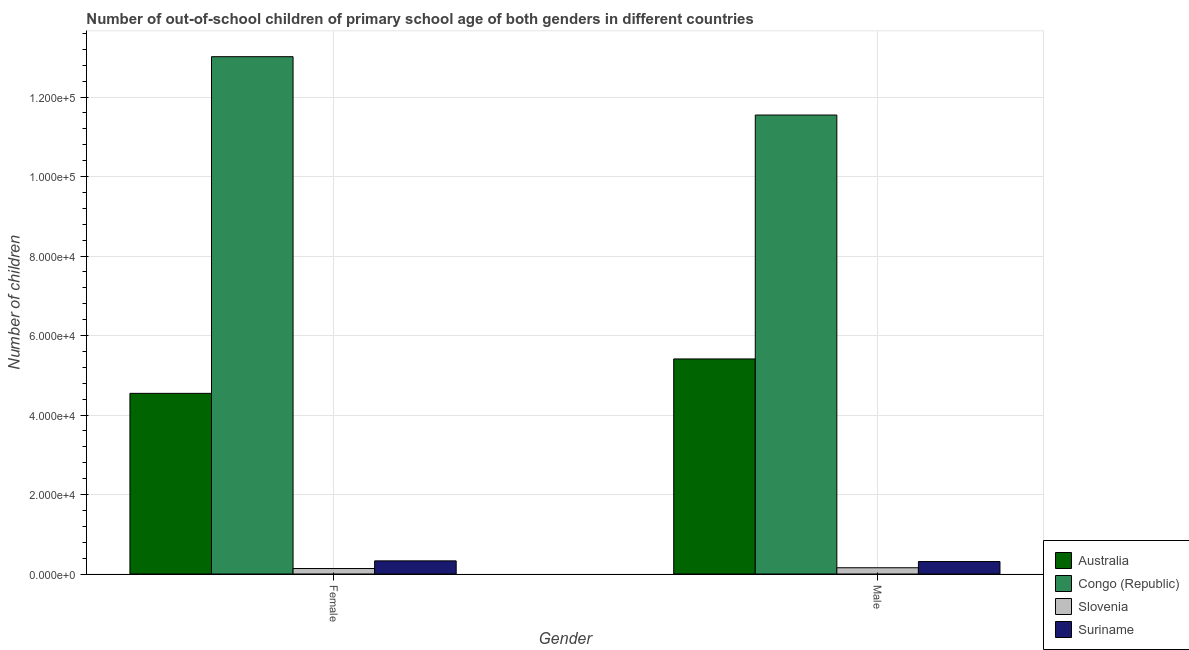Are the number of bars on each tick of the X-axis equal?
Provide a succinct answer. Yes. How many bars are there on the 2nd tick from the right?
Your answer should be very brief. 4. What is the label of the 1st group of bars from the left?
Offer a very short reply. Female. What is the number of male out-of-school students in Australia?
Your response must be concise. 5.41e+04. Across all countries, what is the maximum number of male out-of-school students?
Your answer should be compact. 1.15e+05. Across all countries, what is the minimum number of female out-of-school students?
Give a very brief answer. 1377. In which country was the number of male out-of-school students maximum?
Your answer should be compact. Congo (Republic). In which country was the number of female out-of-school students minimum?
Provide a succinct answer. Slovenia. What is the total number of male out-of-school students in the graph?
Your answer should be compact. 1.74e+05. What is the difference between the number of male out-of-school students in Suriname and that in Australia?
Provide a succinct answer. -5.10e+04. What is the difference between the number of female out-of-school students in Suriname and the number of male out-of-school students in Congo (Republic)?
Your answer should be very brief. -1.12e+05. What is the average number of male out-of-school students per country?
Provide a succinct answer. 4.36e+04. What is the difference between the number of female out-of-school students and number of male out-of-school students in Congo (Republic)?
Provide a succinct answer. 1.47e+04. In how many countries, is the number of female out-of-school students greater than 120000 ?
Your answer should be compact. 1. What is the ratio of the number of female out-of-school students in Slovenia to that in Suriname?
Give a very brief answer. 0.42. In how many countries, is the number of male out-of-school students greater than the average number of male out-of-school students taken over all countries?
Offer a terse response. 2. What does the 4th bar from the right in Female represents?
Offer a very short reply. Australia. How many bars are there?
Your response must be concise. 8. Are all the bars in the graph horizontal?
Your answer should be very brief. No. What is the difference between two consecutive major ticks on the Y-axis?
Your answer should be compact. 2.00e+04. Does the graph contain any zero values?
Provide a succinct answer. No. Does the graph contain grids?
Your response must be concise. Yes. How are the legend labels stacked?
Keep it short and to the point. Vertical. What is the title of the graph?
Provide a succinct answer. Number of out-of-school children of primary school age of both genders in different countries. What is the label or title of the X-axis?
Offer a terse response. Gender. What is the label or title of the Y-axis?
Provide a short and direct response. Number of children. What is the Number of children in Australia in Female?
Your answer should be compact. 4.54e+04. What is the Number of children in Congo (Republic) in Female?
Offer a terse response. 1.30e+05. What is the Number of children in Slovenia in Female?
Provide a short and direct response. 1377. What is the Number of children in Suriname in Female?
Make the answer very short. 3305. What is the Number of children in Australia in Male?
Offer a very short reply. 5.41e+04. What is the Number of children in Congo (Republic) in Male?
Your response must be concise. 1.15e+05. What is the Number of children of Slovenia in Male?
Offer a very short reply. 1572. What is the Number of children of Suriname in Male?
Offer a terse response. 3139. Across all Gender, what is the maximum Number of children of Australia?
Keep it short and to the point. 5.41e+04. Across all Gender, what is the maximum Number of children in Congo (Republic)?
Your answer should be very brief. 1.30e+05. Across all Gender, what is the maximum Number of children of Slovenia?
Give a very brief answer. 1572. Across all Gender, what is the maximum Number of children of Suriname?
Provide a succinct answer. 3305. Across all Gender, what is the minimum Number of children of Australia?
Offer a terse response. 4.54e+04. Across all Gender, what is the minimum Number of children of Congo (Republic)?
Provide a succinct answer. 1.15e+05. Across all Gender, what is the minimum Number of children of Slovenia?
Make the answer very short. 1377. Across all Gender, what is the minimum Number of children in Suriname?
Provide a short and direct response. 3139. What is the total Number of children of Australia in the graph?
Your answer should be compact. 9.96e+04. What is the total Number of children of Congo (Republic) in the graph?
Your response must be concise. 2.46e+05. What is the total Number of children of Slovenia in the graph?
Make the answer very short. 2949. What is the total Number of children of Suriname in the graph?
Give a very brief answer. 6444. What is the difference between the Number of children in Australia in Female and that in Male?
Ensure brevity in your answer.  -8659. What is the difference between the Number of children of Congo (Republic) in Female and that in Male?
Provide a succinct answer. 1.47e+04. What is the difference between the Number of children of Slovenia in Female and that in Male?
Offer a terse response. -195. What is the difference between the Number of children of Suriname in Female and that in Male?
Ensure brevity in your answer.  166. What is the difference between the Number of children of Australia in Female and the Number of children of Congo (Republic) in Male?
Give a very brief answer. -7.00e+04. What is the difference between the Number of children of Australia in Female and the Number of children of Slovenia in Male?
Your answer should be compact. 4.39e+04. What is the difference between the Number of children in Australia in Female and the Number of children in Suriname in Male?
Offer a terse response. 4.23e+04. What is the difference between the Number of children in Congo (Republic) in Female and the Number of children in Slovenia in Male?
Provide a succinct answer. 1.29e+05. What is the difference between the Number of children of Congo (Republic) in Female and the Number of children of Suriname in Male?
Ensure brevity in your answer.  1.27e+05. What is the difference between the Number of children of Slovenia in Female and the Number of children of Suriname in Male?
Your response must be concise. -1762. What is the average Number of children in Australia per Gender?
Offer a terse response. 4.98e+04. What is the average Number of children in Congo (Republic) per Gender?
Offer a very short reply. 1.23e+05. What is the average Number of children of Slovenia per Gender?
Ensure brevity in your answer.  1474.5. What is the average Number of children in Suriname per Gender?
Provide a short and direct response. 3222. What is the difference between the Number of children in Australia and Number of children in Congo (Republic) in Female?
Make the answer very short. -8.47e+04. What is the difference between the Number of children in Australia and Number of children in Slovenia in Female?
Keep it short and to the point. 4.41e+04. What is the difference between the Number of children in Australia and Number of children in Suriname in Female?
Offer a terse response. 4.21e+04. What is the difference between the Number of children of Congo (Republic) and Number of children of Slovenia in Female?
Your response must be concise. 1.29e+05. What is the difference between the Number of children of Congo (Republic) and Number of children of Suriname in Female?
Offer a terse response. 1.27e+05. What is the difference between the Number of children in Slovenia and Number of children in Suriname in Female?
Keep it short and to the point. -1928. What is the difference between the Number of children of Australia and Number of children of Congo (Republic) in Male?
Provide a succinct answer. -6.14e+04. What is the difference between the Number of children of Australia and Number of children of Slovenia in Male?
Provide a short and direct response. 5.25e+04. What is the difference between the Number of children of Australia and Number of children of Suriname in Male?
Give a very brief answer. 5.10e+04. What is the difference between the Number of children in Congo (Republic) and Number of children in Slovenia in Male?
Your response must be concise. 1.14e+05. What is the difference between the Number of children of Congo (Republic) and Number of children of Suriname in Male?
Provide a succinct answer. 1.12e+05. What is the difference between the Number of children of Slovenia and Number of children of Suriname in Male?
Your answer should be very brief. -1567. What is the ratio of the Number of children in Australia in Female to that in Male?
Provide a short and direct response. 0.84. What is the ratio of the Number of children of Congo (Republic) in Female to that in Male?
Your response must be concise. 1.13. What is the ratio of the Number of children of Slovenia in Female to that in Male?
Provide a short and direct response. 0.88. What is the ratio of the Number of children in Suriname in Female to that in Male?
Offer a very short reply. 1.05. What is the difference between the highest and the second highest Number of children of Australia?
Your answer should be compact. 8659. What is the difference between the highest and the second highest Number of children of Congo (Republic)?
Ensure brevity in your answer.  1.47e+04. What is the difference between the highest and the second highest Number of children of Slovenia?
Provide a short and direct response. 195. What is the difference between the highest and the second highest Number of children of Suriname?
Your answer should be compact. 166. What is the difference between the highest and the lowest Number of children in Australia?
Provide a succinct answer. 8659. What is the difference between the highest and the lowest Number of children in Congo (Republic)?
Provide a succinct answer. 1.47e+04. What is the difference between the highest and the lowest Number of children in Slovenia?
Your answer should be compact. 195. What is the difference between the highest and the lowest Number of children in Suriname?
Ensure brevity in your answer.  166. 